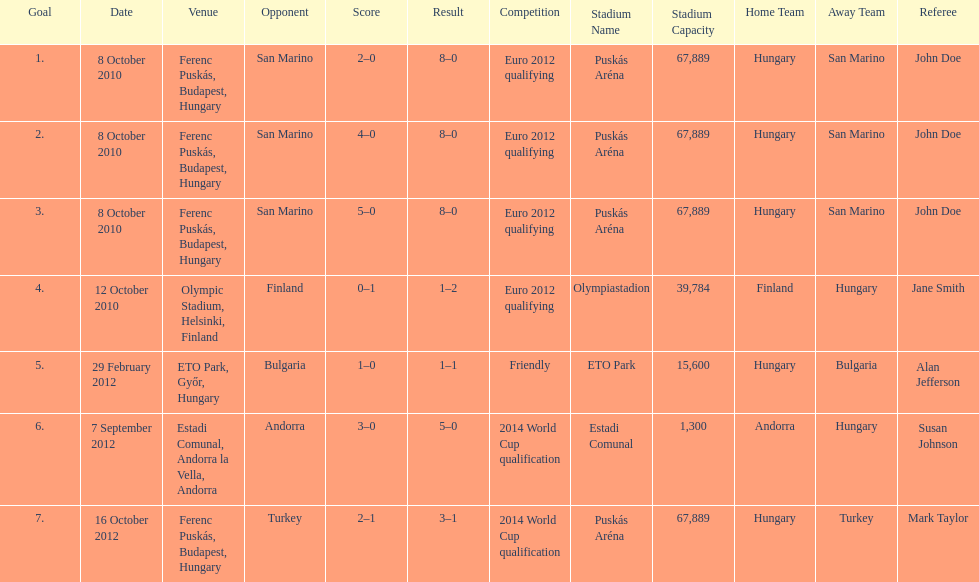How many goals were scored at the euro 2012 qualifying competition? 12. 